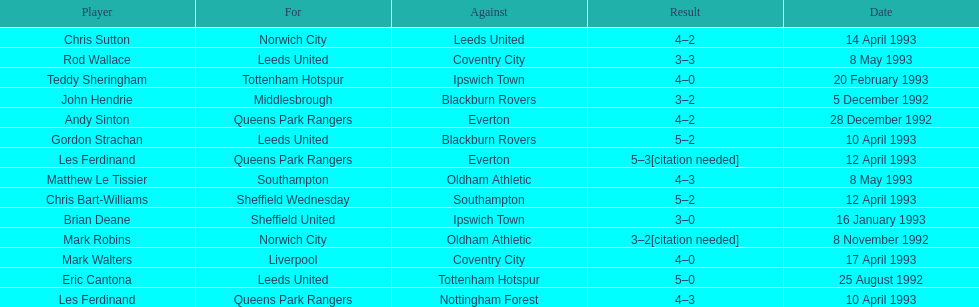How many players were for leeds united? 3. 